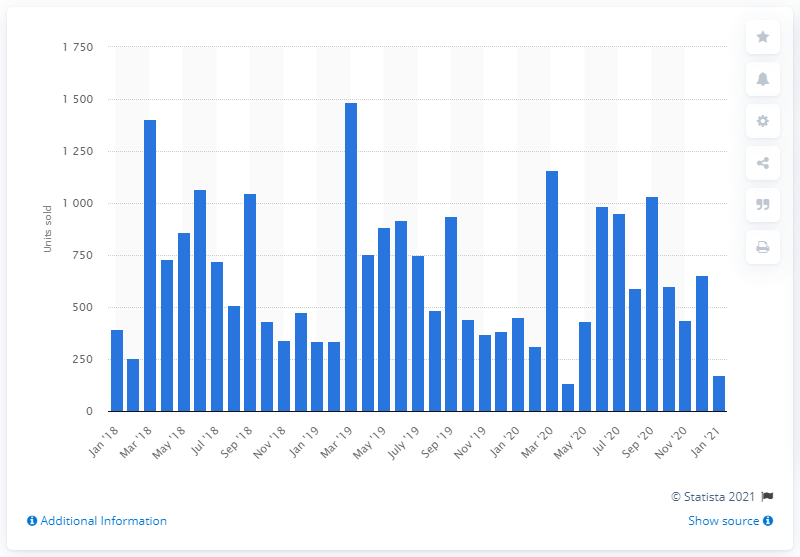Specify some key components in this picture. In January 2021, a total of 173 supersport motorcycles were sold in the UK. 